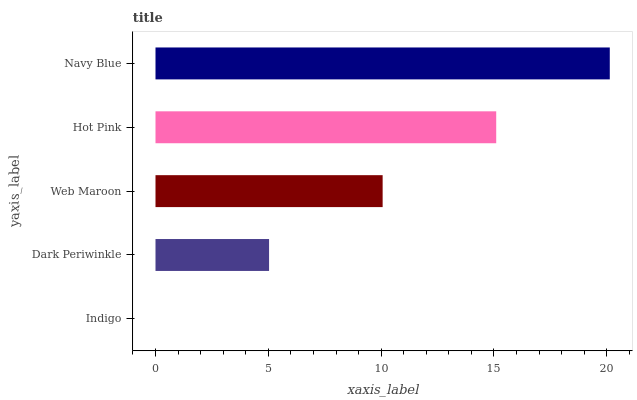Is Indigo the minimum?
Answer yes or no. Yes. Is Navy Blue the maximum?
Answer yes or no. Yes. Is Dark Periwinkle the minimum?
Answer yes or no. No. Is Dark Periwinkle the maximum?
Answer yes or no. No. Is Dark Periwinkle greater than Indigo?
Answer yes or no. Yes. Is Indigo less than Dark Periwinkle?
Answer yes or no. Yes. Is Indigo greater than Dark Periwinkle?
Answer yes or no. No. Is Dark Periwinkle less than Indigo?
Answer yes or no. No. Is Web Maroon the high median?
Answer yes or no. Yes. Is Web Maroon the low median?
Answer yes or no. Yes. Is Dark Periwinkle the high median?
Answer yes or no. No. Is Indigo the low median?
Answer yes or no. No. 